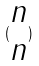Convert formula to latex. <formula><loc_0><loc_0><loc_500><loc_500>( \begin{matrix} n \\ n \end{matrix} )</formula> 